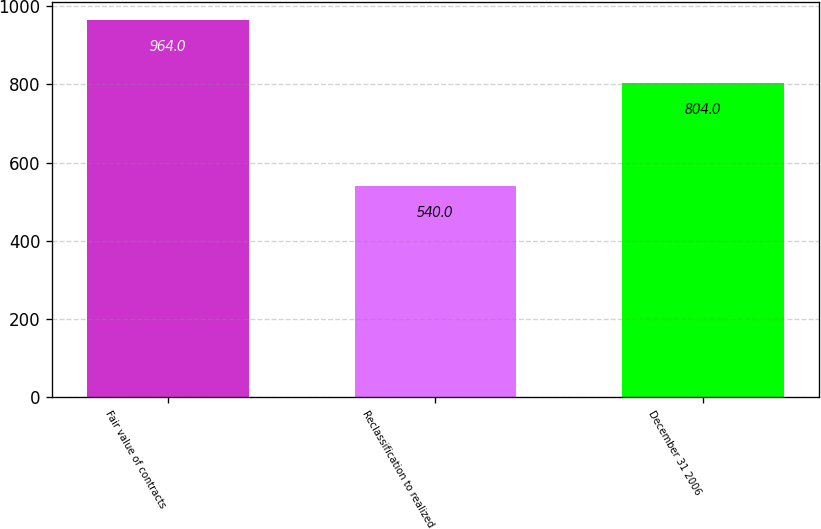Convert chart to OTSL. <chart><loc_0><loc_0><loc_500><loc_500><bar_chart><fcel>Fair value of contracts<fcel>Reclassification to realized<fcel>December 31 2006<nl><fcel>964<fcel>540<fcel>804<nl></chart> 